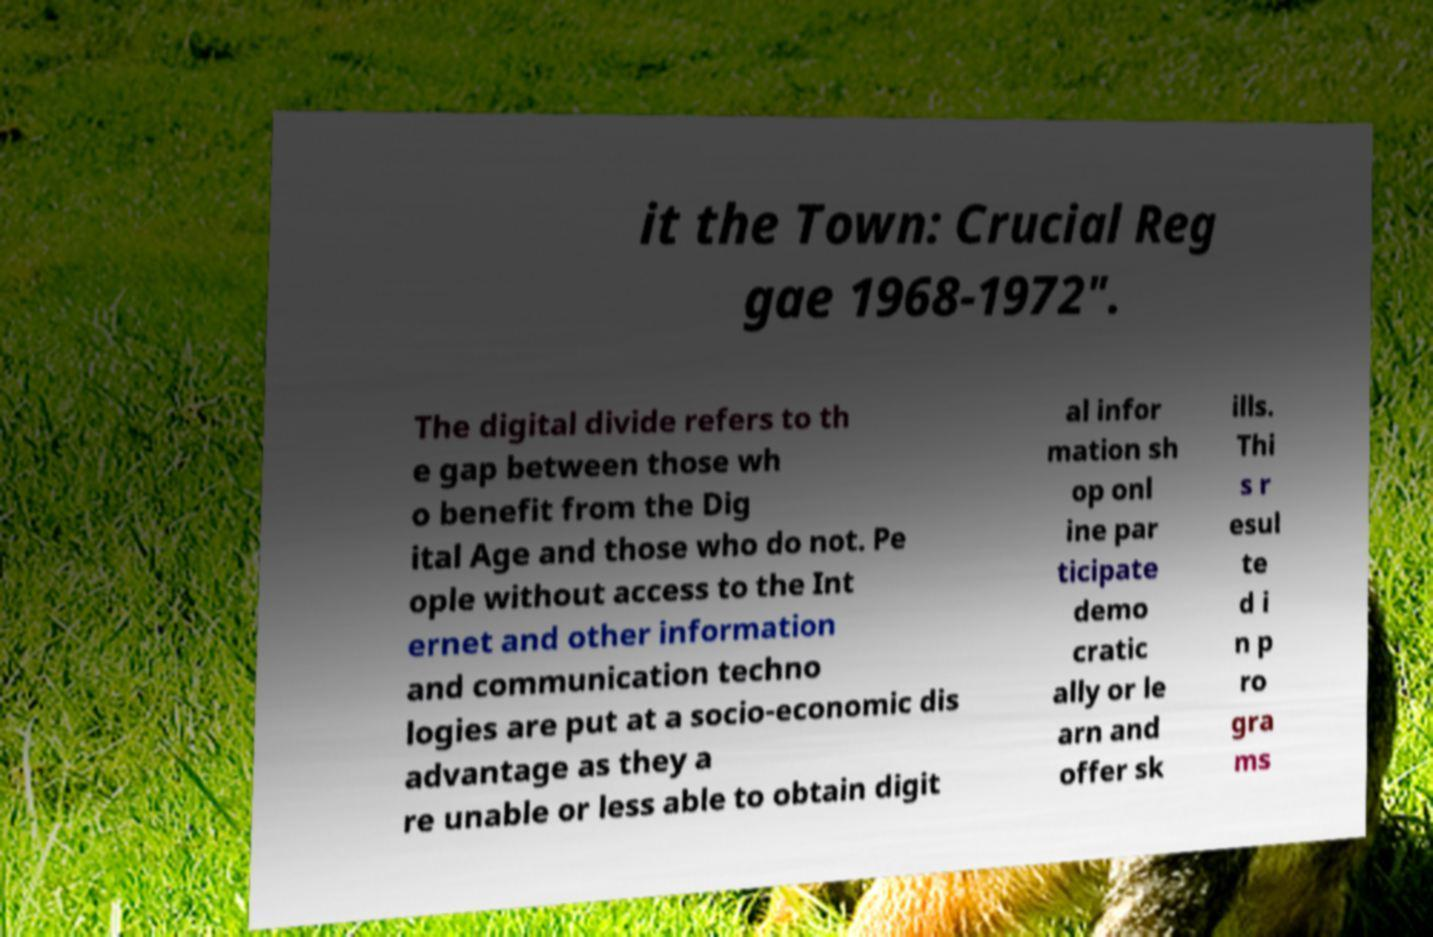Could you extract and type out the text from this image? it the Town: Crucial Reg gae 1968-1972". The digital divide refers to th e gap between those wh o benefit from the Dig ital Age and those who do not. Pe ople without access to the Int ernet and other information and communication techno logies are put at a socio-economic dis advantage as they a re unable or less able to obtain digit al infor mation sh op onl ine par ticipate demo cratic ally or le arn and offer sk ills. Thi s r esul te d i n p ro gra ms 